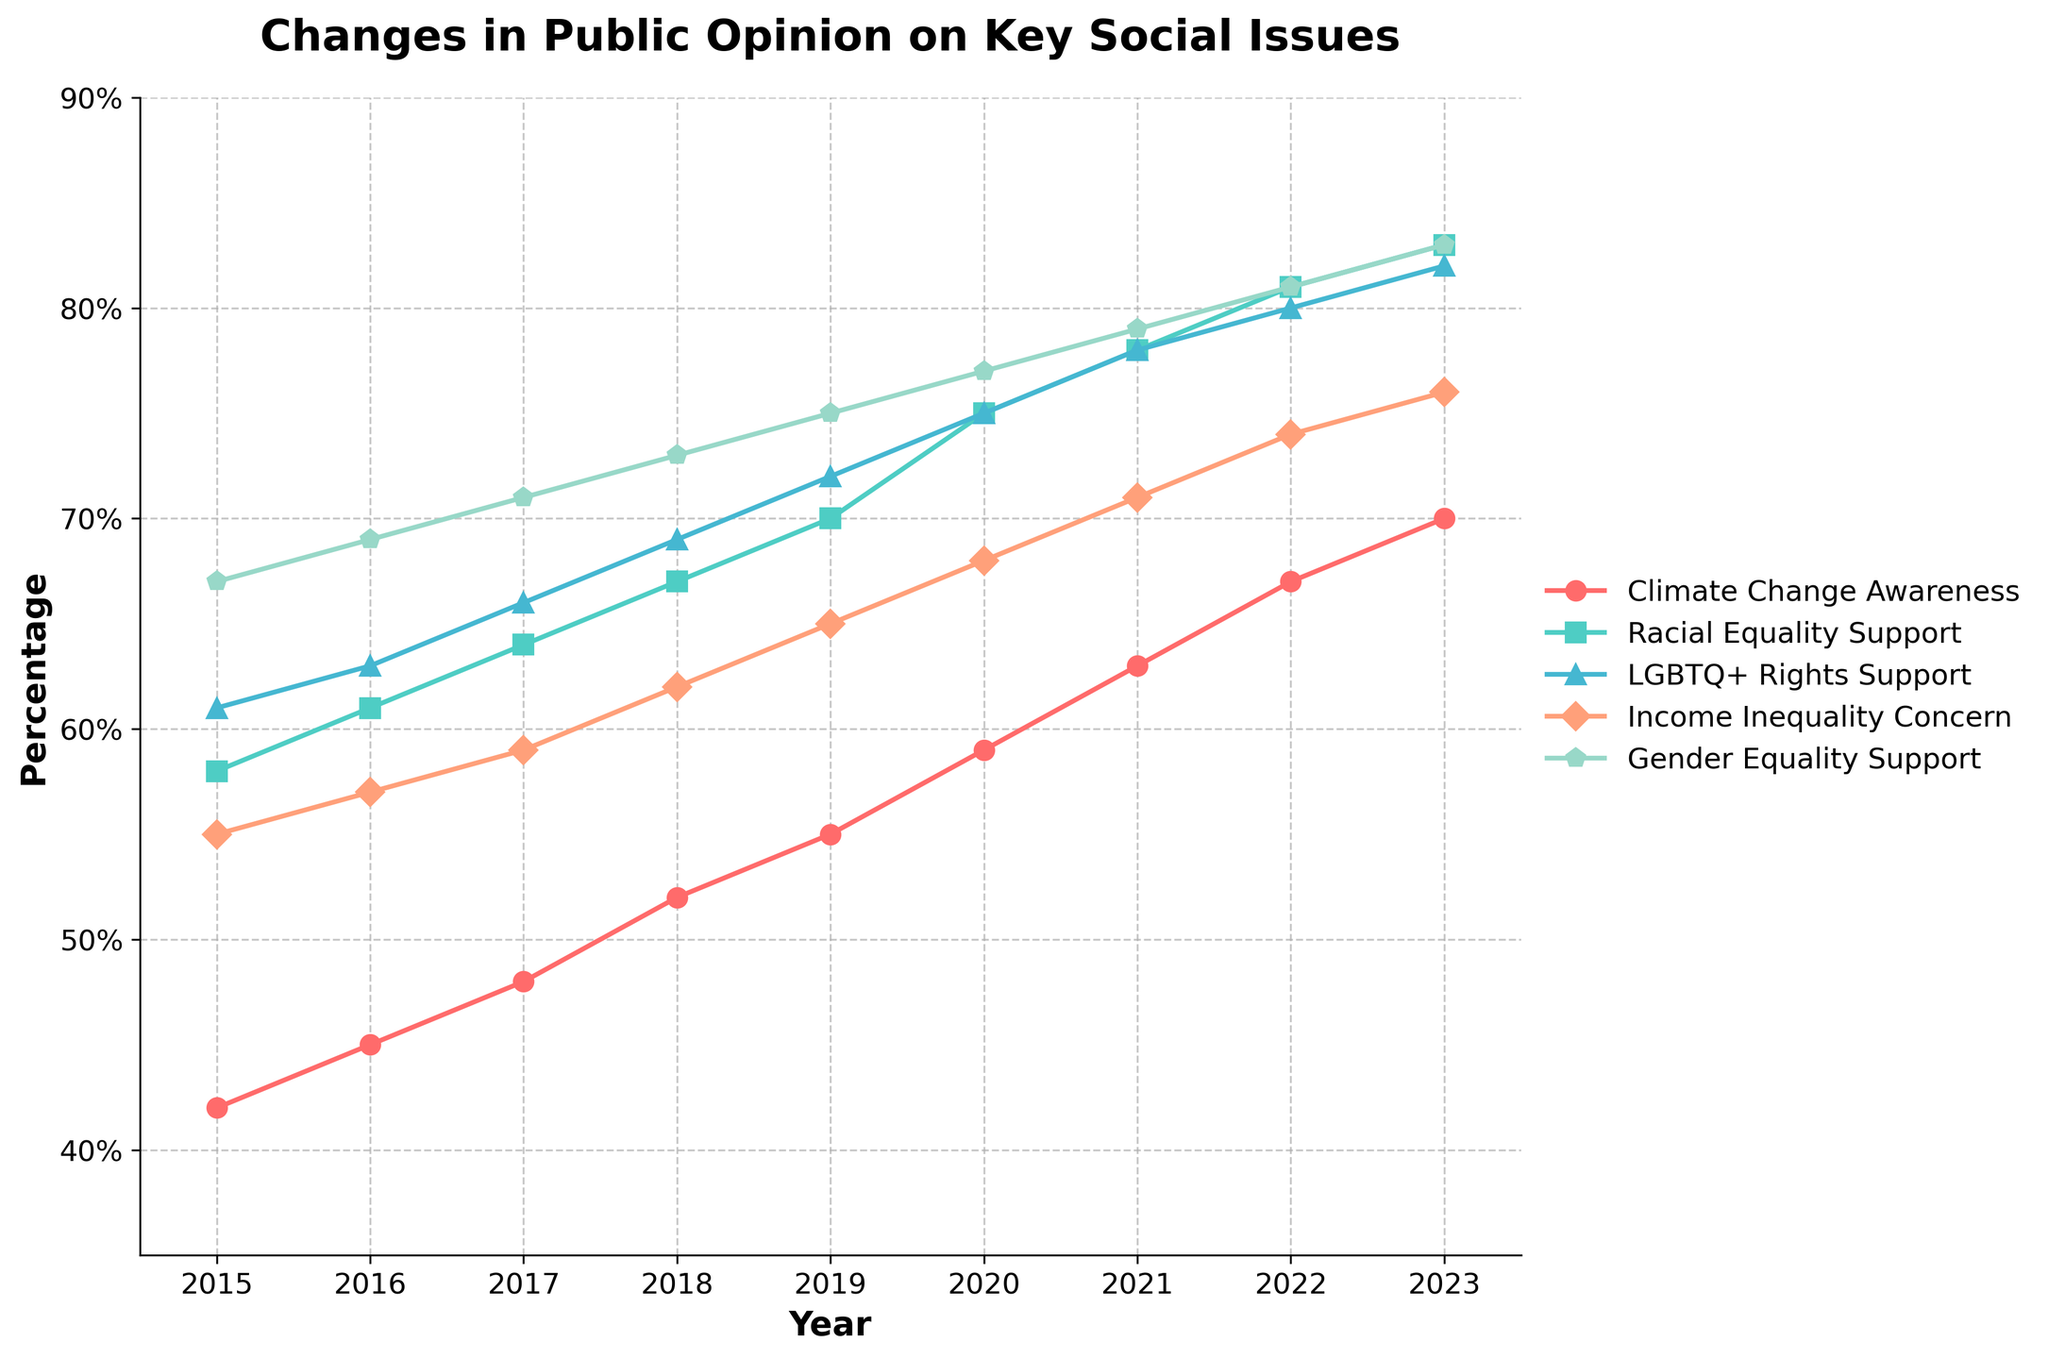Which year shows the highest support for Climate Change Awareness? To determine the highest support for Climate Change Awareness, look at the line labeled for Climate Change Awareness and find the peak point. The highest point is at the end of the line in 2023.
Answer: 2023 Which social issue had the smallest increase in public opinion from 2015 to 2023? Calculate the differences for each social issue between 2015 and 2023: Climate Change Awareness (70-42=28), Racial Equality Support (83-58=25), LGBTQ+ Rights Support (82-61=21), Income Inequality Concern (76-55=21), Gender Equality Support (83-67=16). The smallest increase is in Gender Equality Support.
Answer: Gender Equality Support In which year did support for Racial Equality surpass 75%? To find this, locate the line for Racial Equality Support and see when it crosses the 75% line. The point where the line first goes above 75% is in 2020.
Answer: 2020 Which issue shows the steepest increase between 2019 and 2020? Look at the slopes of the lines between 2019 and 2020. Climate Change Awareness increases from 55 to 59 (+4), Racial Equality Support from 70 to 75 (+5), LGBTQ+ Rights Support from 72 to 75 (+3), Income Inequality Concern from 65 to 68 (+3), Gender Equality Support from 75 to 77 (+2). The steepest slope (largest increase) is for Racial Equality Support.
Answer: Racial Equality Support Compare the support levels of LGBTQ+ Rights Support and Income Inequality Concern in 2021. Which one is higher? In 2021, locate the points for LGBTQ+ Rights Support (78%) and Income Inequality Concern (71%) and compare them. LGBTQ+ Rights Support is higher.
Answer: LGBTQ+ Rights Support What is the average support for Gender Equality Support from 2015 to 2023? Add the percentages for Gender Equality Support from 2015 to 2023 (67 + 69 + 71 + 73 + 75 + 77 + 79 + 81 + 83 = 675) and divide by the number of years (9). Average is 675/9.
Answer: 75 Did support for Climate Change Awareness ever decrease from one year to the next? Review the line for Climate Change Awareness for any dips between consecutive years. There are no points where support decreases; it consistently increases over time.
Answer: No By how much did support for Income Inequality Concern increase from 2015 to 2020? Subtract the 2015 value (55) from the 2020 value (68). The increase is 68 - 55 = 13.
Answer: 13 Which social issue was closest to 60% support in 2018? Look at the values for each social issue in 2018: Climate Change Awareness (52), Racial Equality Support (67), LGBTQ+ Rights Support (69), Income Inequality Concern (62), Gender Equality Support (73). Income Inequality Concern, which stands at 62%, is closest to 60%.
Answer: Income Inequality Concern Between 2017 and 2018, which issue showed an increase of exactly 3%? Check the differences for each issue between 2017 and 2018: Climate Change Awareness (52-48=4), Racial Equality Support (67-64=3), LGBTQ+ Rights Support (69-66=3), Income Inequality Concern (62-59=3), Gender Equality Support (73-71=2). Both Racial Equality Support, LGBTQ+ Rights Support, and Income Inequality Concern showed an exact 3% increase.
Answer: Racial Equality Support, LGBTQ+ Rights Support, Income Inequality Concern 